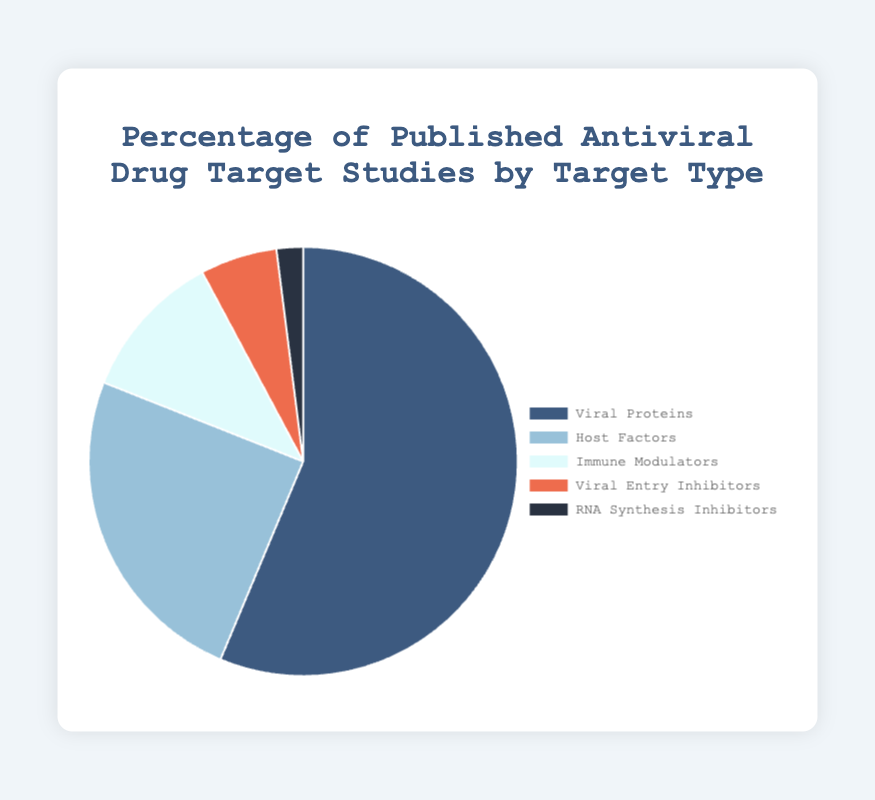What percentage of studies focus on Viral Proteins? The chart shows that Viral Proteins are represented as 56.3%.
Answer: 56.3% How many times higher is the percentage of studies on Viral Proteins compared to RNA Synthesis Inhibitors? To find the multiple, divide the percentage for Viral Proteins (56.3%) by that for RNA Synthesis Inhibitors (2.0%). 56.3 / 2.0 = 28.15.
Answer: 28.15 times Which target type has the second-highest percentage of studies? The target type with the second-highest percentage is Host Factors at 24.7%, as indicated by its placement in the chart.
Answer: Host Factors What is the combined percentage of studies focusing on Host Factors and Immune Modulators? Add the percentages of Host Factors (24.7%) and Immune Modulators (11.2%). 24.7 + 11.2 = 35.9%.
Answer: 35.9% Compare the number of studies on Viral Entry Inhibitors to Immune Modulators in terms of percentage. Immune Modulators account for 11.2% of studies, while Viral Entry Inhibitors account for 5.8%. By subtracting, 11.2 - 5.8 = 5.4%. Therefore, Immune Modulators have 5.4% more studies.
Answer: 5.4% more Which target type is the least studied according to the chart? The chart shows that RNA Synthesis Inhibitors have the smallest percentage of studies with only 2.0%.
Answer: RNA Synthesis Inhibitors What color represents the Host Factors in the chart? The color used for Host Factors on the chart is a shade of blue (light blue).
Answer: Light blue If we combined the percentages of Viral Entry Inhibitors and RNA Synthesis Inhibitors, would this new group surpass the percentage of Immune Modulators? Add the percentages of Viral Entry Inhibitors (5.8%) and RNA Synthesis Inhibitors (2.0%). 5.8 + 2.0 = 7.8%. This is less than Immune Modulators at 11.2%.
Answer: No By how much does the percentage of studies on Host Factors exceed that of Viral Entry Inhibitors? Subtract the percentage of Viral Entry Inhibitors (5.8%) from Host Factors (24.7%). 24.7 - 5.8 = 18.9%.
Answer: 18.9% What proportion of studies focus on target types other than Viral Proteins? Sum the percentages of all other target types (24.7% + 11.2% + 5.8% + 2.0%). 24.7 + 11.2 + 5.8 + 2.0 = 43.7%.
Answer: 43.7% 